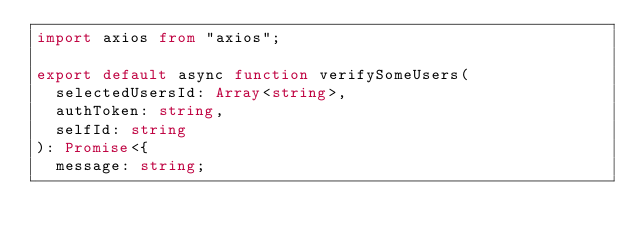Convert code to text. <code><loc_0><loc_0><loc_500><loc_500><_TypeScript_>import axios from "axios";

export default async function verifySomeUsers(
  selectedUsersId: Array<string>,
  authToken: string,
  selfId: string
): Promise<{
  message: string;</code> 